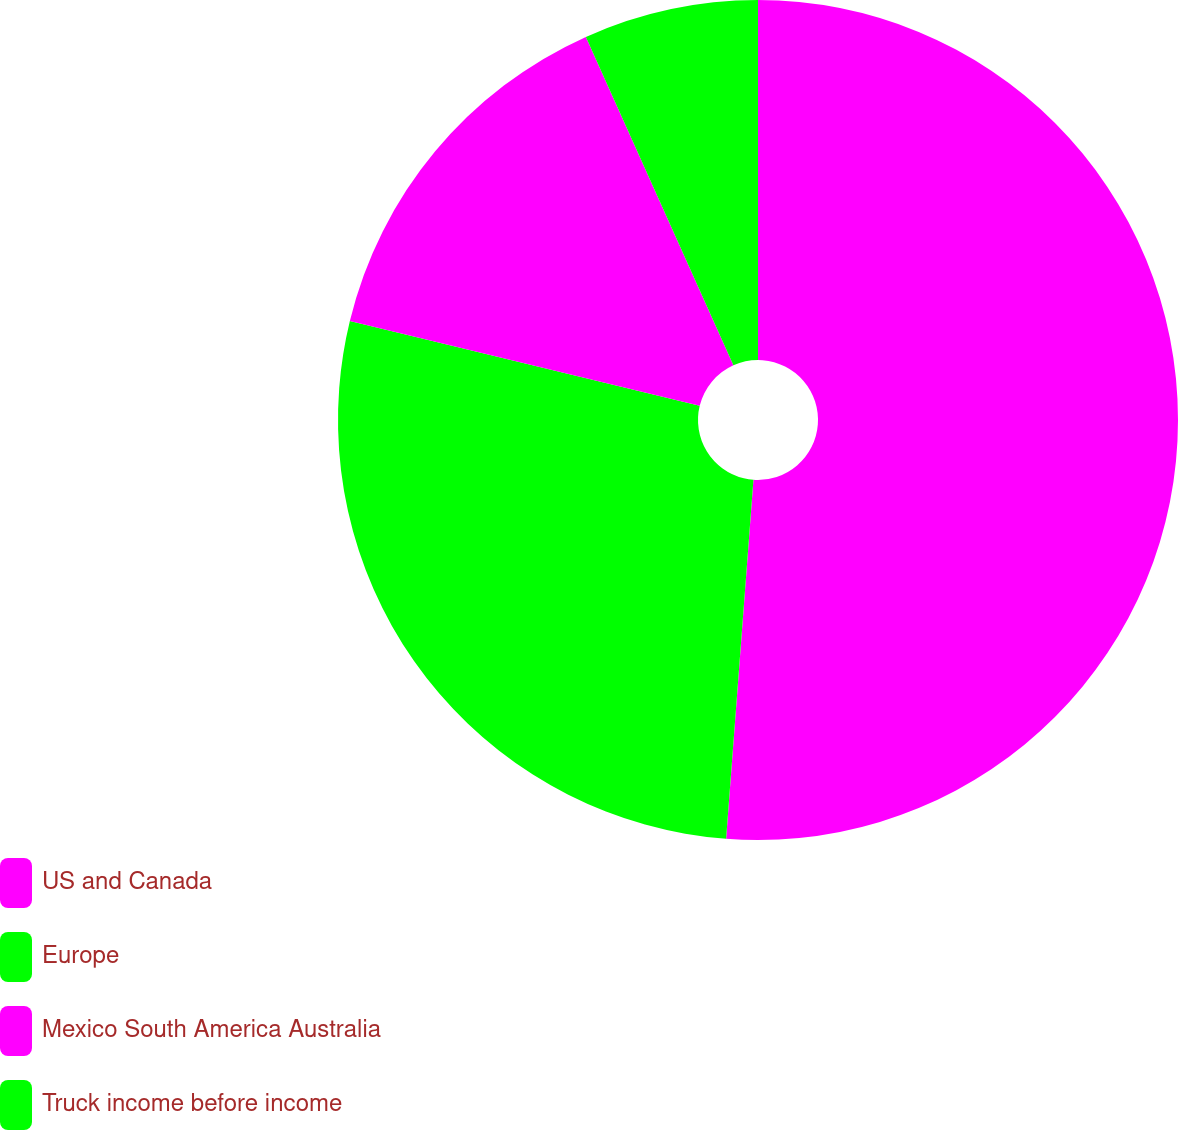Convert chart. <chart><loc_0><loc_0><loc_500><loc_500><pie_chart><fcel>US and Canada<fcel>Europe<fcel>Mexico South America Australia<fcel>Truck income before income<nl><fcel>51.21%<fcel>27.58%<fcel>14.49%<fcel>6.72%<nl></chart> 